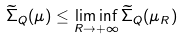<formula> <loc_0><loc_0><loc_500><loc_500>\widetilde { \Sigma } _ { Q } ( \mu ) \leq \liminf _ { R \to + \infty } \widetilde { \Sigma } _ { Q } ( \mu _ { R } )</formula> 